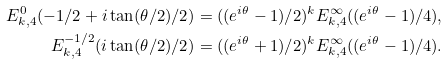<formula> <loc_0><loc_0><loc_500><loc_500>E _ { k , 4 } ^ { 0 } ( - 1 / 2 + i \tan ( \theta / 2 ) / 2 ) = ( ( e ^ { i \theta } - 1 ) / 2 ) ^ { k } E _ { k , 4 } ^ { \infty } ( ( e ^ { i \theta } - 1 ) / 4 ) , \\ E _ { k , 4 } ^ { - 1 / 2 } ( i \tan ( \theta / 2 ) / 2 ) = ( ( e ^ { i \theta } + 1 ) / 2 ) ^ { k } E _ { k , 4 } ^ { \infty } ( ( e ^ { i \theta } - 1 ) / 4 ) .</formula> 